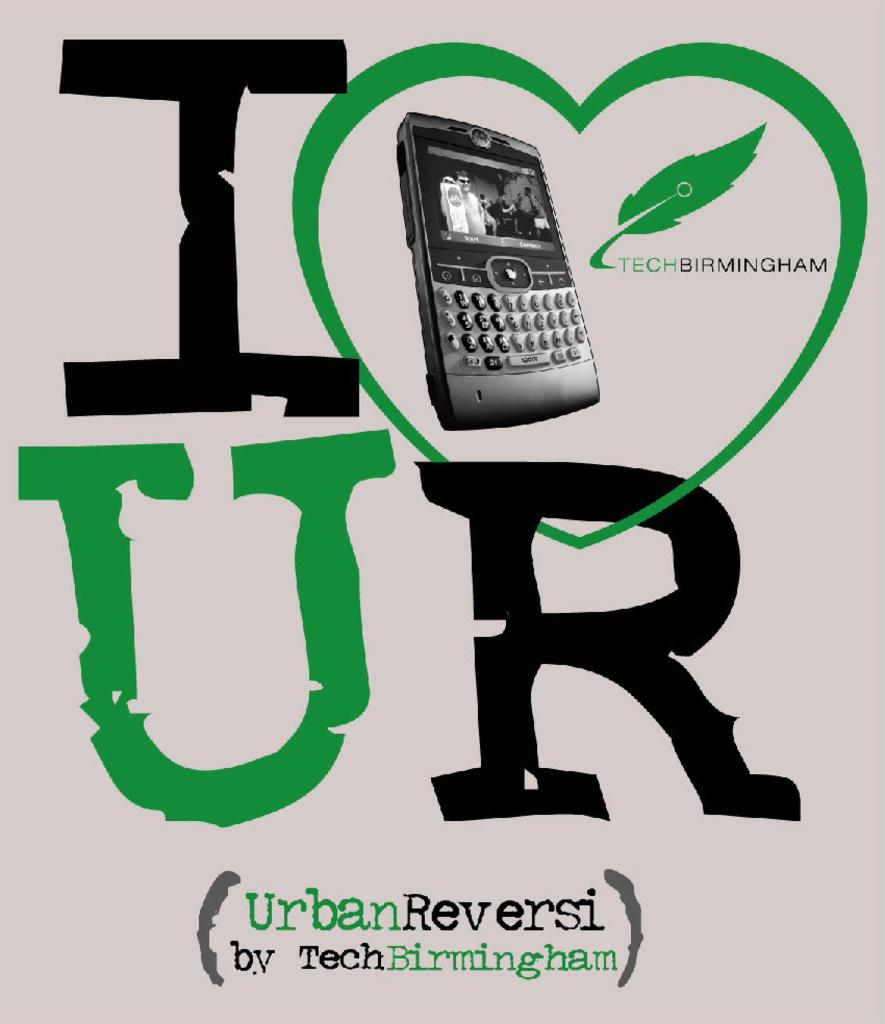What is the main subject in the center of the image? There is a poster in the center of the image. What is depicted on the poster? The poster features a phone. Are there any words or letters on the poster? Yes, there is text on the poster. Can you see the moon in the image? No, the moon is not present in the image; it features a poster with a phone and text. 